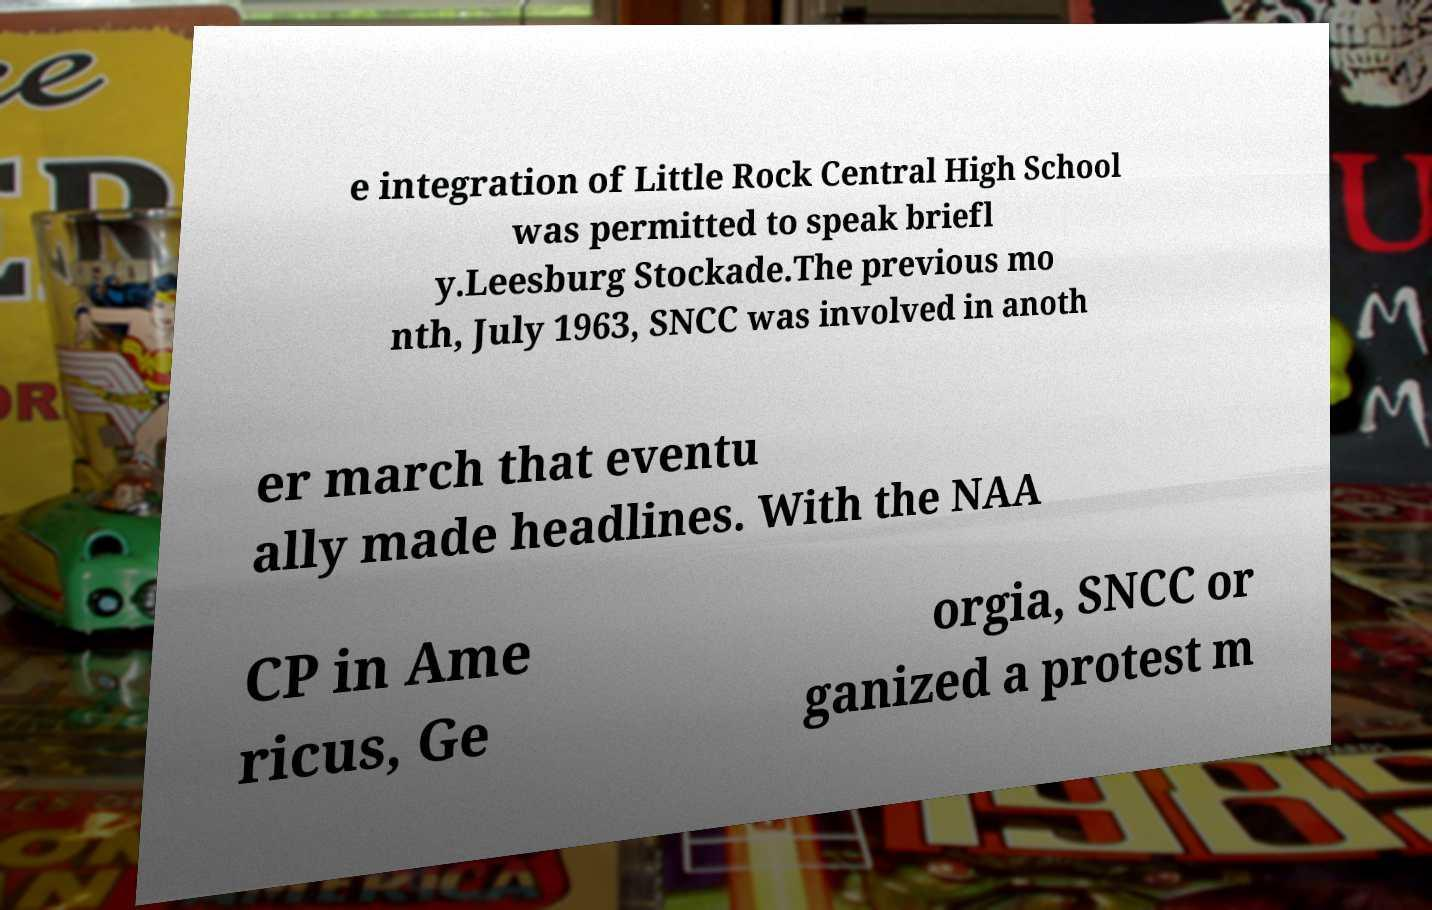What messages or text are displayed in this image? I need them in a readable, typed format. e integration of Little Rock Central High School was permitted to speak briefl y.Leesburg Stockade.The previous mo nth, July 1963, SNCC was involved in anoth er march that eventu ally made headlines. With the NAA CP in Ame ricus, Ge orgia, SNCC or ganized a protest m 